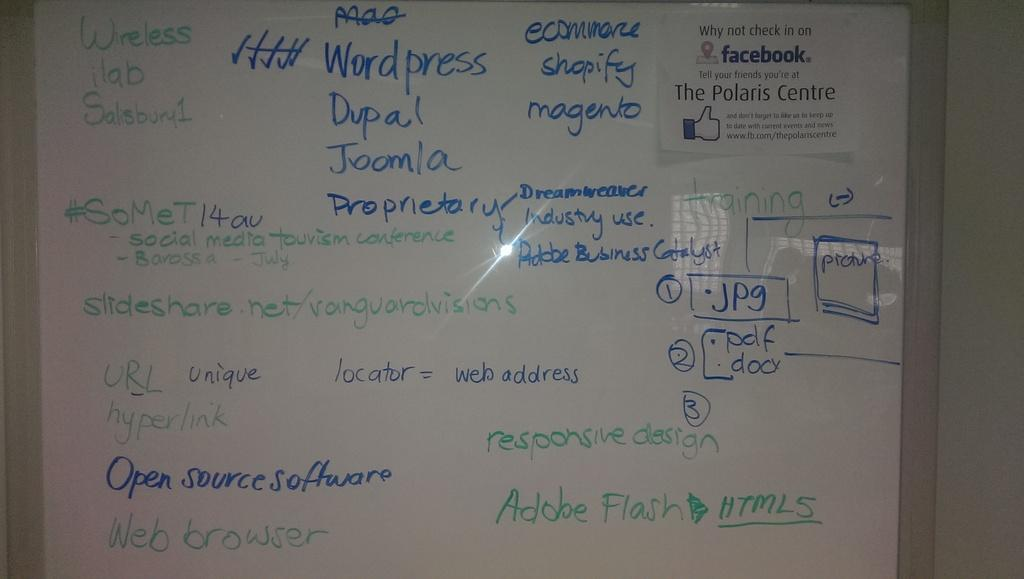<image>
Describe the image concisely. White board with blue letters that say "Open Sources Software" on the bonttom. 